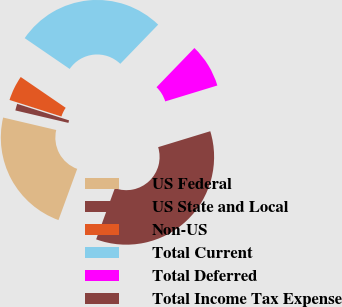Convert chart to OTSL. <chart><loc_0><loc_0><loc_500><loc_500><pie_chart><fcel>US Federal<fcel>US State and Local<fcel>Non-US<fcel>Total Current<fcel>Total Deferred<fcel>Total Income Tax Expense<nl><fcel>23.09%<fcel>1.24%<fcel>4.65%<fcel>27.67%<fcel>8.05%<fcel>35.3%<nl></chart> 